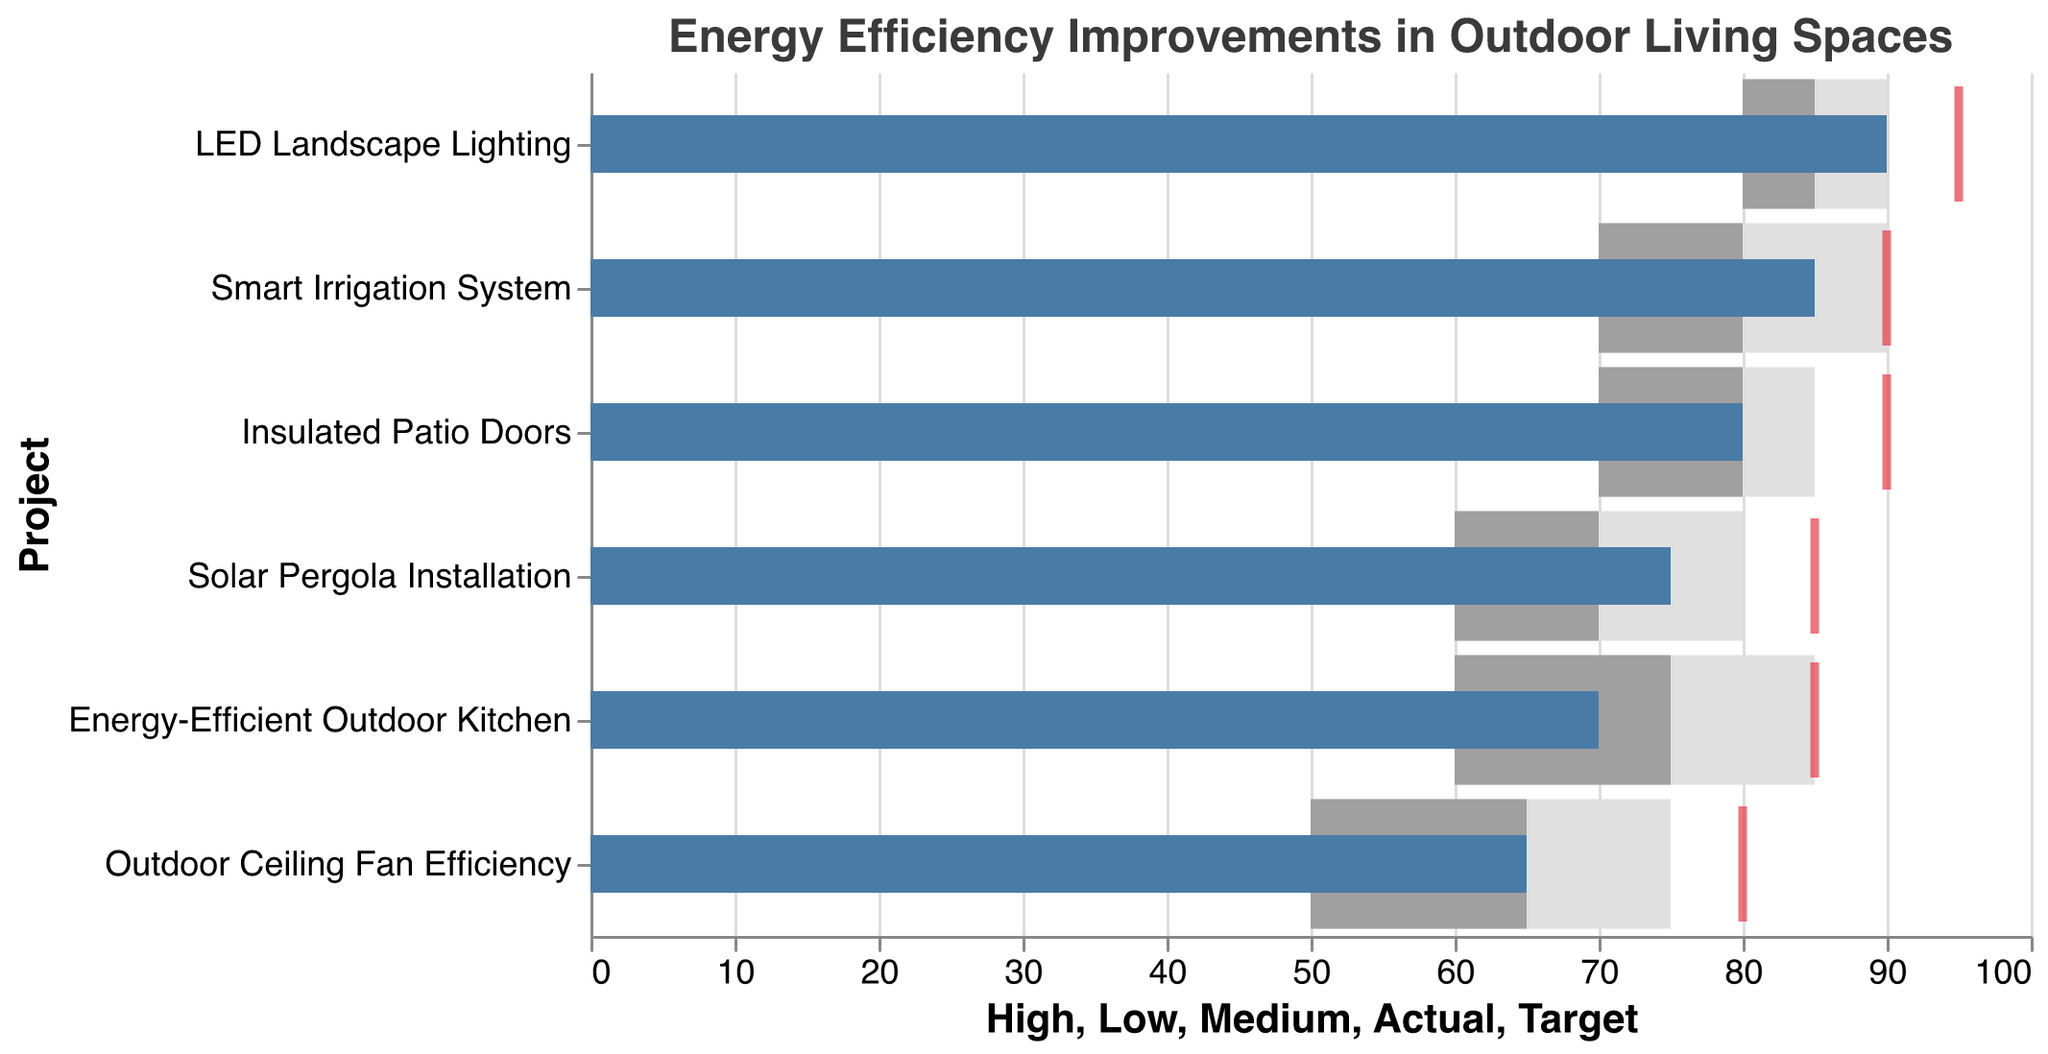What is the title of the chart? The title of the chart is "Energy Efficiency Improvements in Outdoor Living Spaces," which is displayed prominently at the top of the chart.
Answer: Energy Efficiency Improvements in Outdoor Living Spaces How many projects are depicted in the chart? The chart shows six projects, which can be identified by counting the number of distinct project names along the y-axis.
Answer: Six Which project has the highest actual improvement percentage? The project with the highest actual improvement percentage is identified by finding the project with the highest bar in blue. The "LED Landscape Lighting" project has the highest actual improvement of 90%.
Answer: LED Landscape Lighting How does the actual improvement of "Smart Irrigation System" compare to its target? Compare the blue bar to the red tick for "Smart Irrigation System." The actual improvement is 85%, while the target is 90%, so the actual improvement is lower than the target.
Answer: Lower What is the difference between the actual and target improvements for "Insulated Patio Doors"? Subtract the actual improvement value from the target improvement value for "Insulated Patio Doors." The target is 90%, and the actual is 80%, so the difference is 90% - 80% = 10%.
Answer: 10% Which project is closest to meeting its target improvement percentage? Determine the project where the blue bar's value is closest to the red tick. For "Smart Irrigation System," the actual improvement of 85% is closest to its target of 90%, with a difference of only 5%.
Answer: Smart Irrigation System What is the range of the medium improvement zone for "Outdoor Ceiling Fan Efficiency"? The medium improvement zone is represented by the dark grey bar, starting at the low end of the medium and ending at the high end of the medium. For "Outdoor Ceiling Fan Efficiency," it ranges from 65% to 75%.
Answer: 65% to 75% How many projects have an actual improvement below the high improvement zone? Inspect where the blue bars fall below the top of the light grey zones (high improvement). Three projects fall below the high improvement zone: "Solar Pergola Installation," "Outdoor Ceiling Fan Efficiency," and "Energy-Efficient Outdoor Kitchen."
Answer: Three Which project has the widest range between its low and high improvement zones? The range can be calculated by subtracting the low end from the high end of the light grey bar for each project. "Energy-Efficient Outdoor Kitchen" has the widest range: 85% - 60% = 25%.
Answer: Energy-Efficient Outdoor Kitchen 